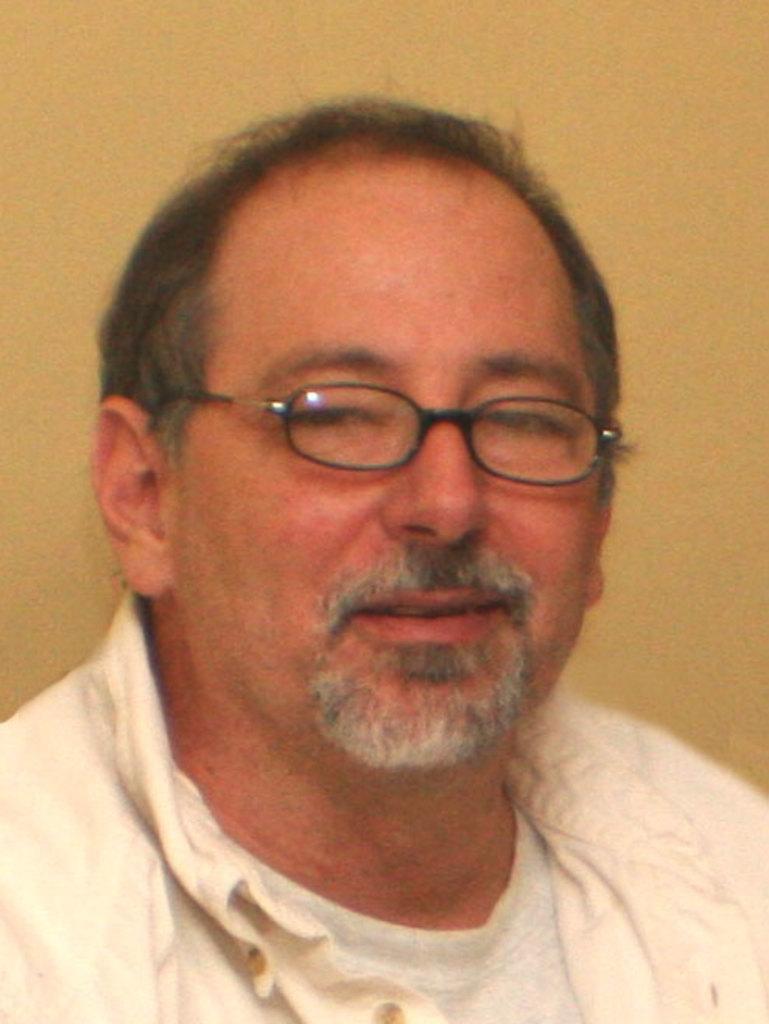Please provide a concise description of this image. In this picture we can see a man holding a pretty smile on his face. He wore spectacles which are black in colour. He is wearing a white jacket over a white shirt. 